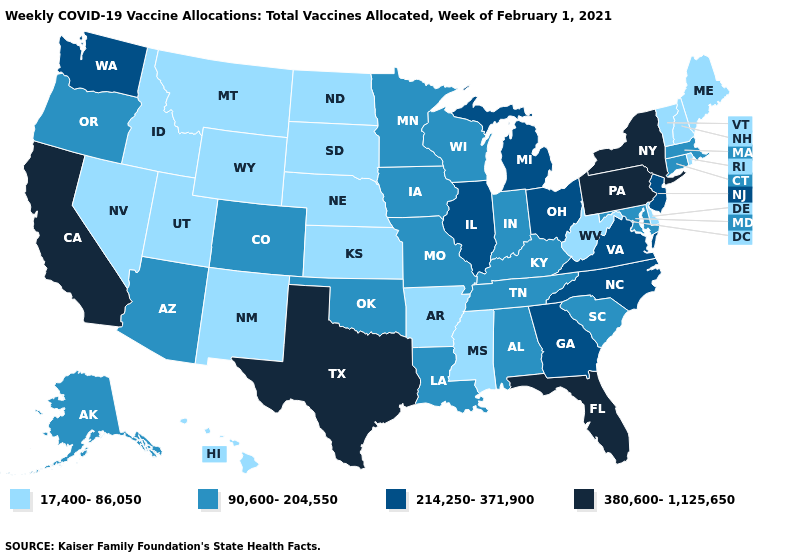What is the lowest value in the South?
Give a very brief answer. 17,400-86,050. What is the value of West Virginia?
Write a very short answer. 17,400-86,050. Does Indiana have a higher value than North Dakota?
Be succinct. Yes. What is the value of Wisconsin?
Be succinct. 90,600-204,550. Which states have the highest value in the USA?
Be succinct. California, Florida, New York, Pennsylvania, Texas. Does Maryland have the highest value in the USA?
Concise answer only. No. Name the states that have a value in the range 380,600-1,125,650?
Keep it brief. California, Florida, New York, Pennsylvania, Texas. Among the states that border Nebraska , does Iowa have the highest value?
Quick response, please. Yes. Name the states that have a value in the range 17,400-86,050?
Write a very short answer. Arkansas, Delaware, Hawaii, Idaho, Kansas, Maine, Mississippi, Montana, Nebraska, Nevada, New Hampshire, New Mexico, North Dakota, Rhode Island, South Dakota, Utah, Vermont, West Virginia, Wyoming. Among the states that border Mississippi , which have the lowest value?
Be succinct. Arkansas. What is the value of Idaho?
Quick response, please. 17,400-86,050. Which states hav the highest value in the West?
Concise answer only. California. Which states have the highest value in the USA?
Give a very brief answer. California, Florida, New York, Pennsylvania, Texas. Does Virginia have the highest value in the South?
Answer briefly. No. Among the states that border Utah , which have the highest value?
Answer briefly. Arizona, Colorado. 